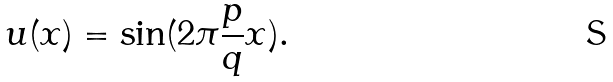Convert formula to latex. <formula><loc_0><loc_0><loc_500><loc_500>u ( x ) = \sin ( 2 \pi \frac { p } { q } x ) .</formula> 